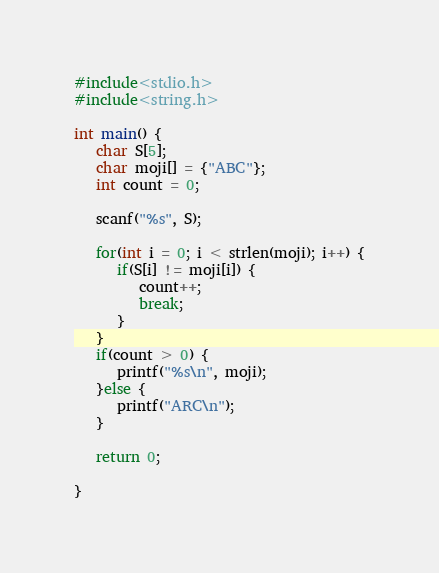Convert code to text. <code><loc_0><loc_0><loc_500><loc_500><_C_>#include<stdio.h>
#include<string.h>

int main() {
   char S[5];
   char moji[] = {"ABC"};
   int count = 0;

   scanf("%s", S);

   for(int i = 0; i < strlen(moji); i++) {
      if(S[i] != moji[i]) {
         count++;
         break;
      }
   }
   if(count > 0) {
      printf("%s\n", moji);
   }else {
      printf("ARC\n");
   }

   return 0;

}
</code> 